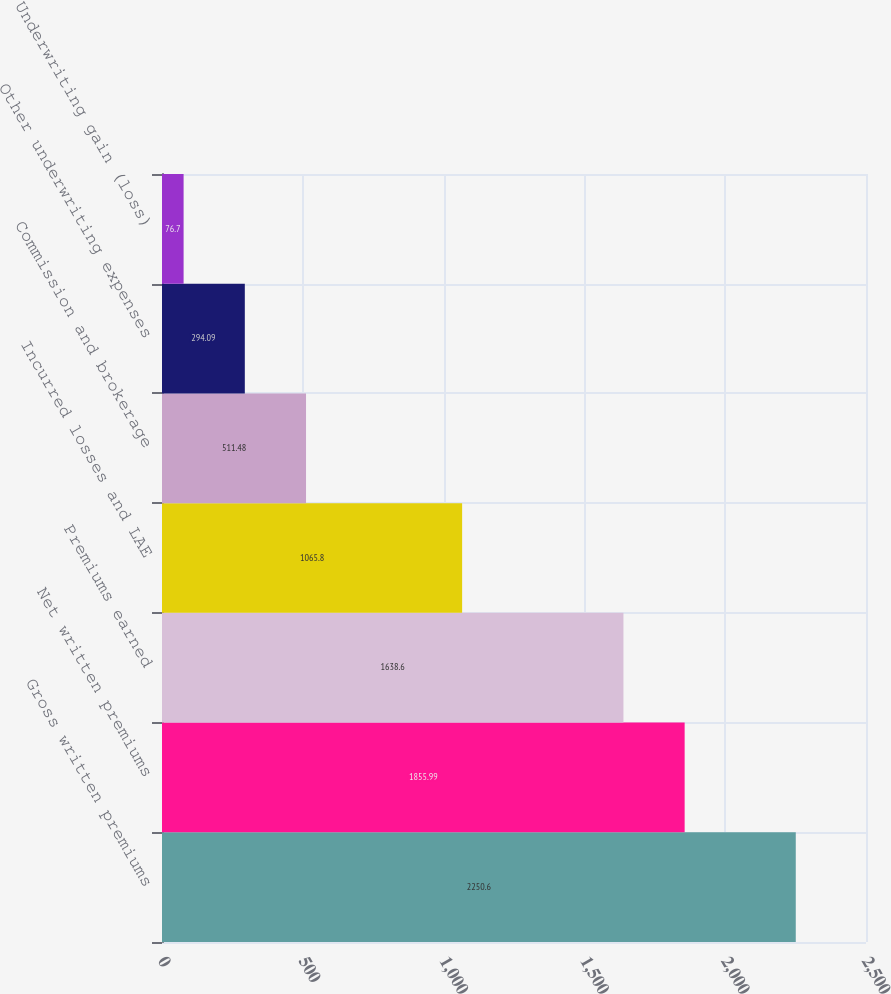Convert chart to OTSL. <chart><loc_0><loc_0><loc_500><loc_500><bar_chart><fcel>Gross written premiums<fcel>Net written premiums<fcel>Premiums earned<fcel>Incurred losses and LAE<fcel>Commission and brokerage<fcel>Other underwriting expenses<fcel>Underwriting gain (loss)<nl><fcel>2250.6<fcel>1855.99<fcel>1638.6<fcel>1065.8<fcel>511.48<fcel>294.09<fcel>76.7<nl></chart> 